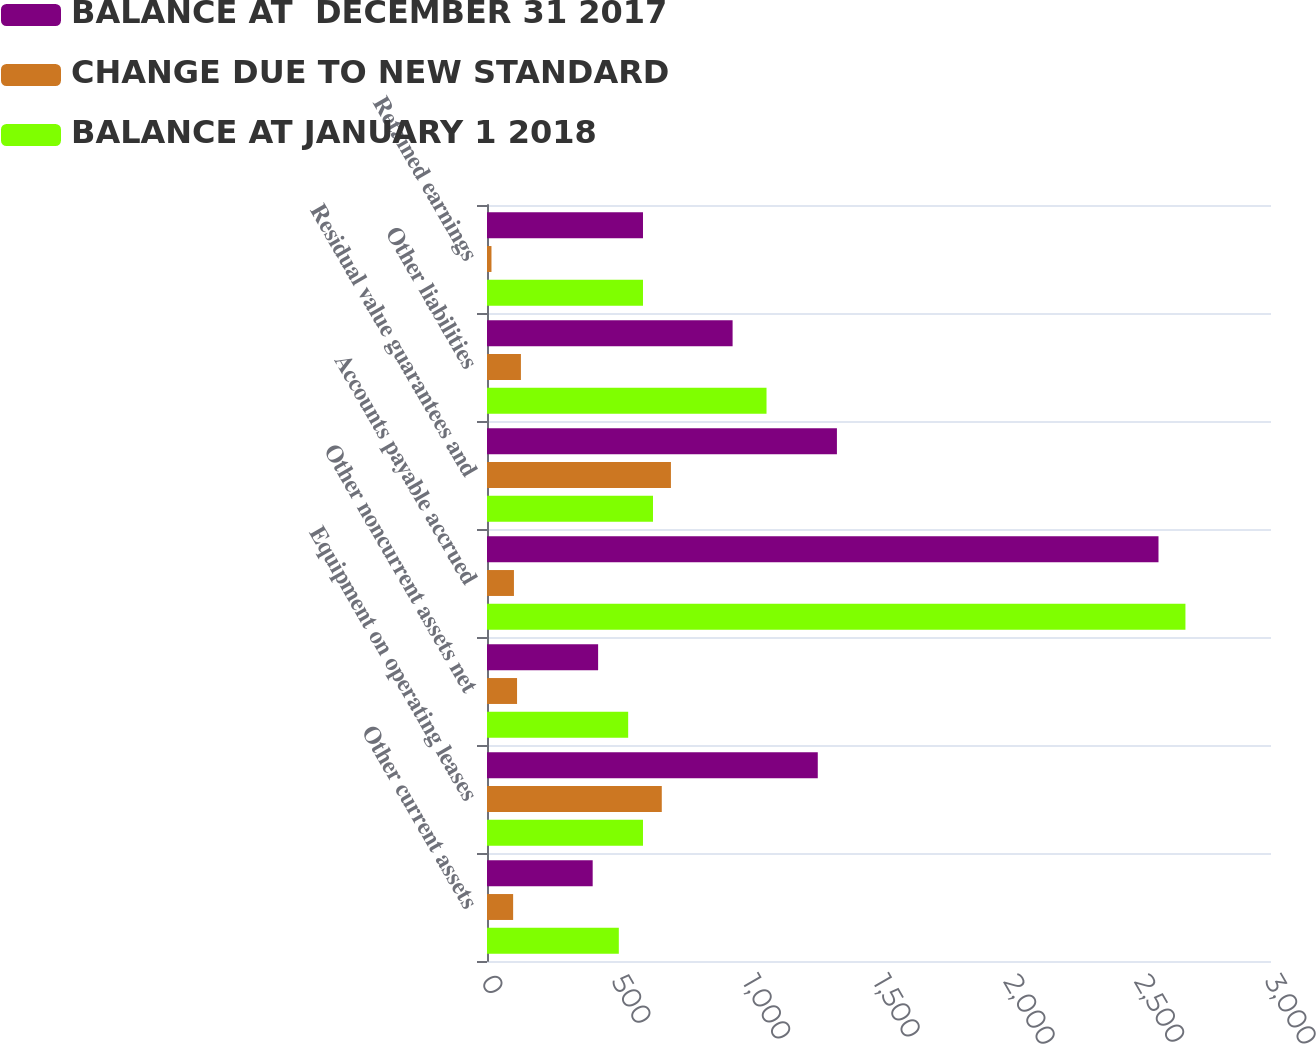<chart> <loc_0><loc_0><loc_500><loc_500><stacked_bar_chart><ecel><fcel>Other current assets<fcel>Equipment on operating leases<fcel>Other noncurrent assets net<fcel>Accounts payable accrued<fcel>Residual value guarantees and<fcel>Other liabilities<fcel>Retained earnings<nl><fcel>BALANCE AT  DECEMBER 31 2017<fcel>404.4<fcel>1265.7<fcel>425.2<fcel>2569.5<fcel>1339<fcel>939.8<fcel>596.9<nl><fcel>CHANGE DUE TO NEW STANDARD<fcel>100<fcel>668.8<fcel>115<fcel>103.1<fcel>703.8<fcel>129.8<fcel>17.1<nl><fcel>BALANCE AT JANUARY 1 2018<fcel>504.4<fcel>596.9<fcel>540.2<fcel>2672.6<fcel>635.2<fcel>1069.6<fcel>596.9<nl></chart> 